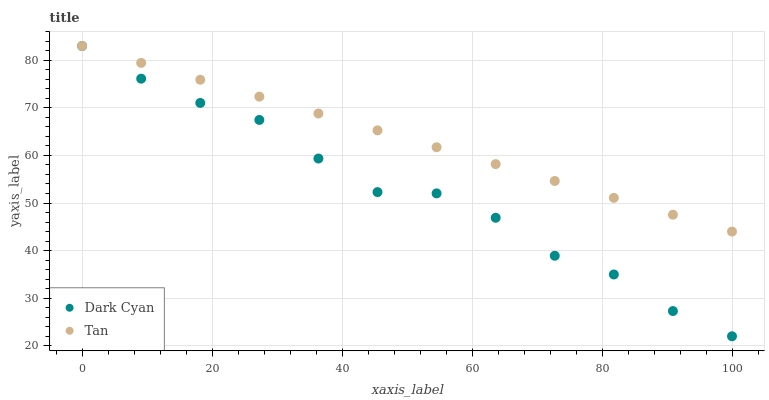Does Dark Cyan have the minimum area under the curve?
Answer yes or no. Yes. Does Tan have the maximum area under the curve?
Answer yes or no. Yes. Does Tan have the minimum area under the curve?
Answer yes or no. No. Is Tan the smoothest?
Answer yes or no. Yes. Is Dark Cyan the roughest?
Answer yes or no. Yes. Is Tan the roughest?
Answer yes or no. No. Does Dark Cyan have the lowest value?
Answer yes or no. Yes. Does Tan have the lowest value?
Answer yes or no. No. Does Tan have the highest value?
Answer yes or no. Yes. Does Dark Cyan intersect Tan?
Answer yes or no. Yes. Is Dark Cyan less than Tan?
Answer yes or no. No. Is Dark Cyan greater than Tan?
Answer yes or no. No. 